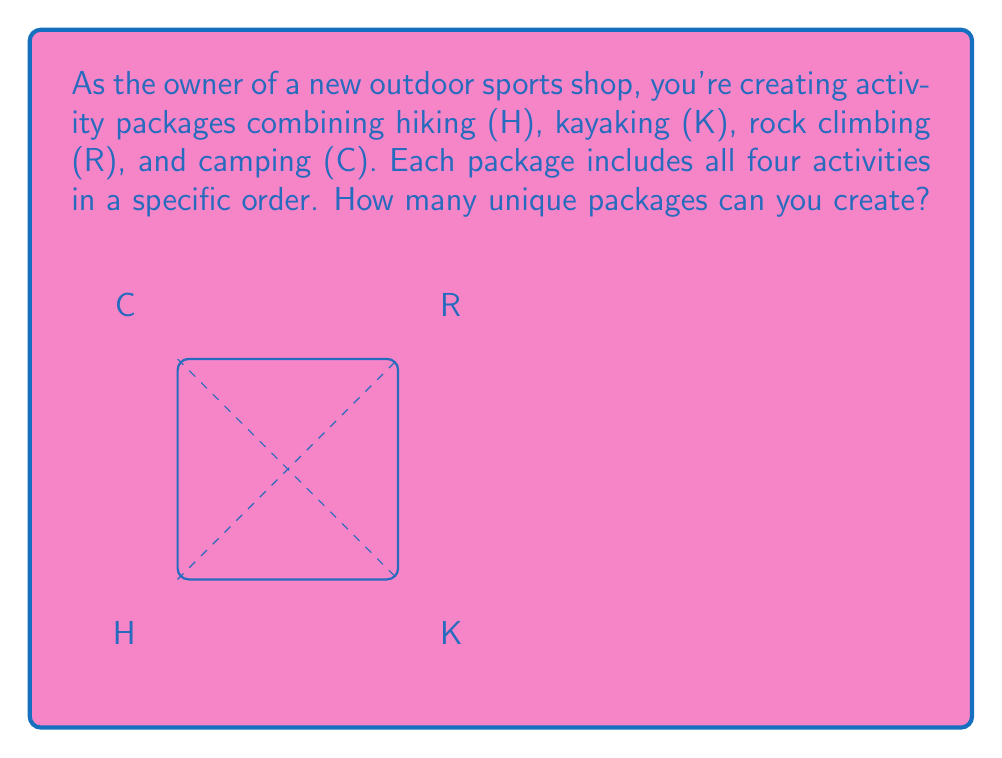Give your solution to this math problem. To solve this problem, we need to understand the concept of permutations in group theory.

1) We have 4 distinct activities: H, K, R, and C.

2) We want to arrange all 4 activities in different orders. This is a permutation problem.

3) The number of permutations of n distinct objects is given by n!

4) In this case, n = 4

5) Therefore, the number of unique packages is 4! = 4 × 3 × 2 × 1 = 24

6) In group theory terms, this is equivalent to finding the order of the symmetric group $S_4$.

7) The symmetric group $S_n$ is the group of all permutations on n elements, and its order is always n!

8) So, the order of the permutation group for scheduling these outdoor activity packages is |$S_4$| = 4! = 24

This means you can create 24 different activity packages by arranging these 4 activities in different orders.
Answer: 24 